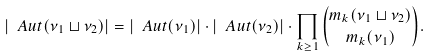<formula> <loc_0><loc_0><loc_500><loc_500>\left | \ A u t ( \nu _ { 1 } \sqcup \nu _ { 2 } ) \right | = \left | \ A u t ( \nu _ { 1 } ) \right | \cdot \left | \ A u t ( \nu _ { 2 } ) \right | \cdot \prod _ { k \geq 1 } \binom { m _ { k } ( \nu _ { 1 } \sqcup \nu _ { 2 } ) } { m _ { k } ( \nu _ { 1 } ) } .</formula> 